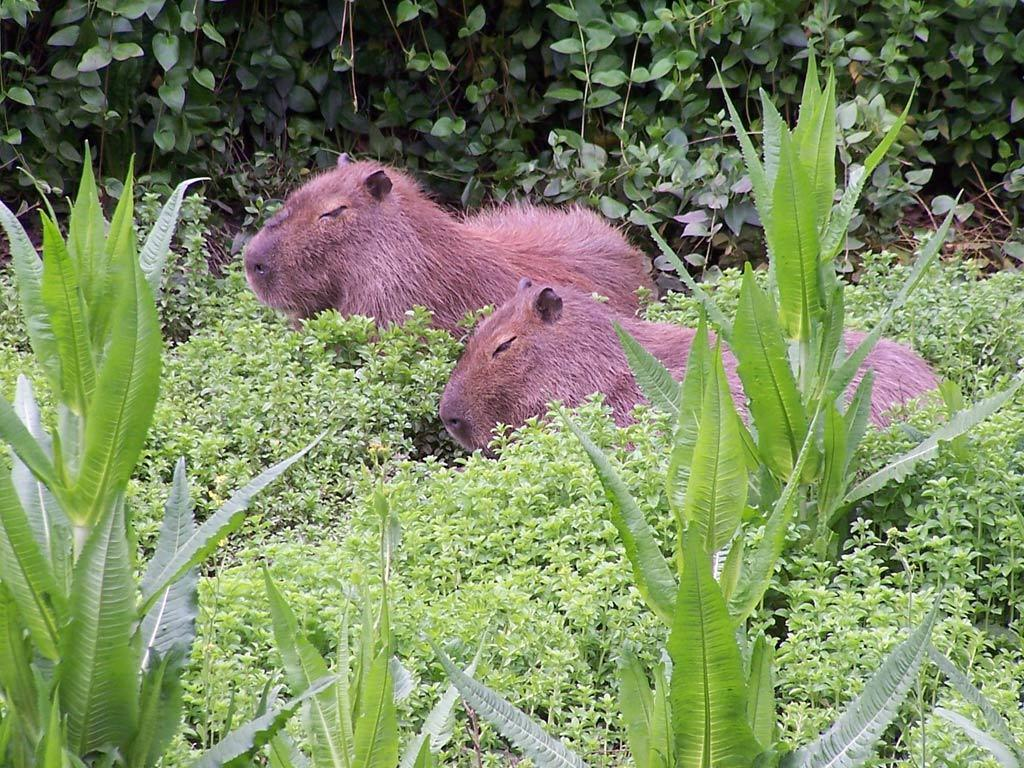What is located in the center of the image? There are two animals in the center of the image. What can be seen at the bottom of the image? There are plants at the bottom of the image. What is visible in the background of the image? There are trees in the background of the image. How much wealth is represented by the needle in the image? There is no needle present in the image, and therefore no wealth can be associated with it. 